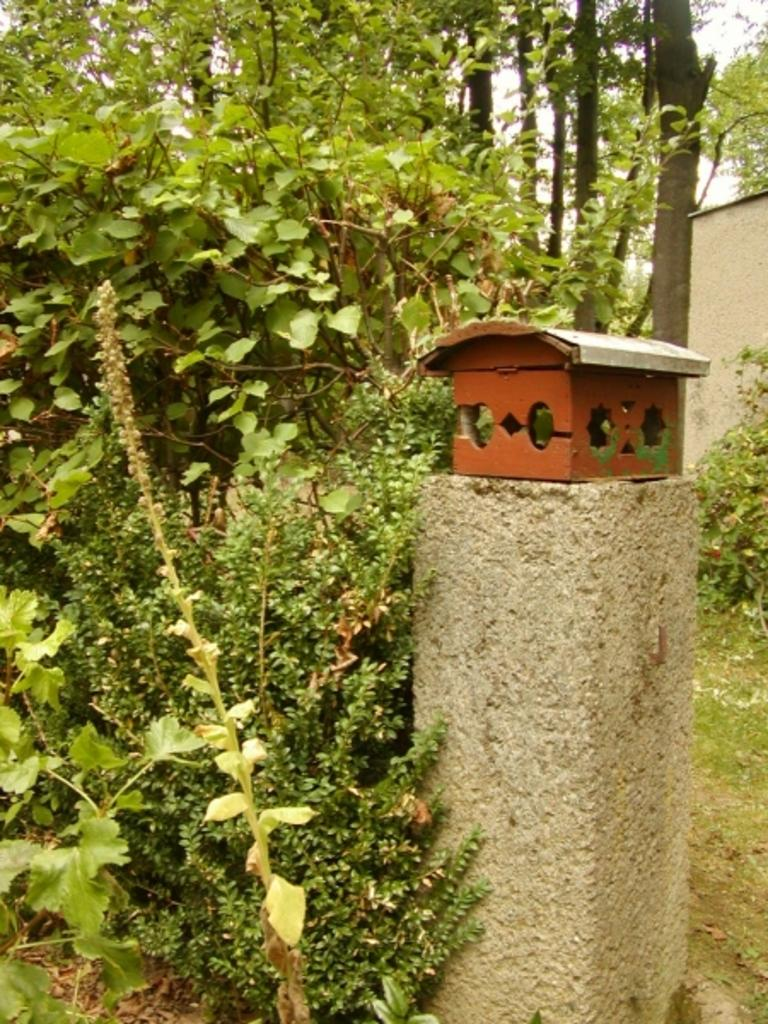What object is located on the surface in the image? There is a box on the surface in the image. What type of vegetation can be seen in the image? There are plants and grass in the image. What can be seen in the background of the image? There are trees, a wall, and the sky visible in the background of the image. What shape is the land in the image? The image does not depict land; it shows a box on a surface, plants, grass, trees, a wall, and the sky. What is the condition of the plants in the image? The provided facts do not give information about the condition of the plants, so we cannot determine if they are healthy, wilted, or any other condition. 